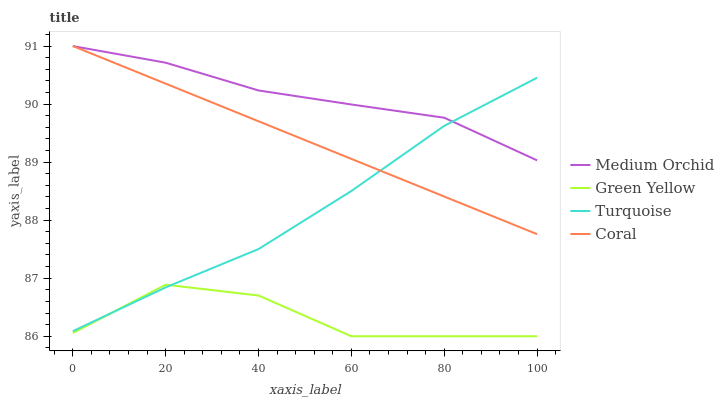Does Green Yellow have the minimum area under the curve?
Answer yes or no. Yes. Does Medium Orchid have the maximum area under the curve?
Answer yes or no. Yes. Does Medium Orchid have the minimum area under the curve?
Answer yes or no. No. Does Green Yellow have the maximum area under the curve?
Answer yes or no. No. Is Coral the smoothest?
Answer yes or no. Yes. Is Green Yellow the roughest?
Answer yes or no. Yes. Is Medium Orchid the smoothest?
Answer yes or no. No. Is Medium Orchid the roughest?
Answer yes or no. No. Does Green Yellow have the lowest value?
Answer yes or no. Yes. Does Medium Orchid have the lowest value?
Answer yes or no. No. Does Coral have the highest value?
Answer yes or no. Yes. Does Medium Orchid have the highest value?
Answer yes or no. No. Is Green Yellow less than Medium Orchid?
Answer yes or no. Yes. Is Medium Orchid greater than Green Yellow?
Answer yes or no. Yes. Does Turquoise intersect Medium Orchid?
Answer yes or no. Yes. Is Turquoise less than Medium Orchid?
Answer yes or no. No. Is Turquoise greater than Medium Orchid?
Answer yes or no. No. Does Green Yellow intersect Medium Orchid?
Answer yes or no. No. 